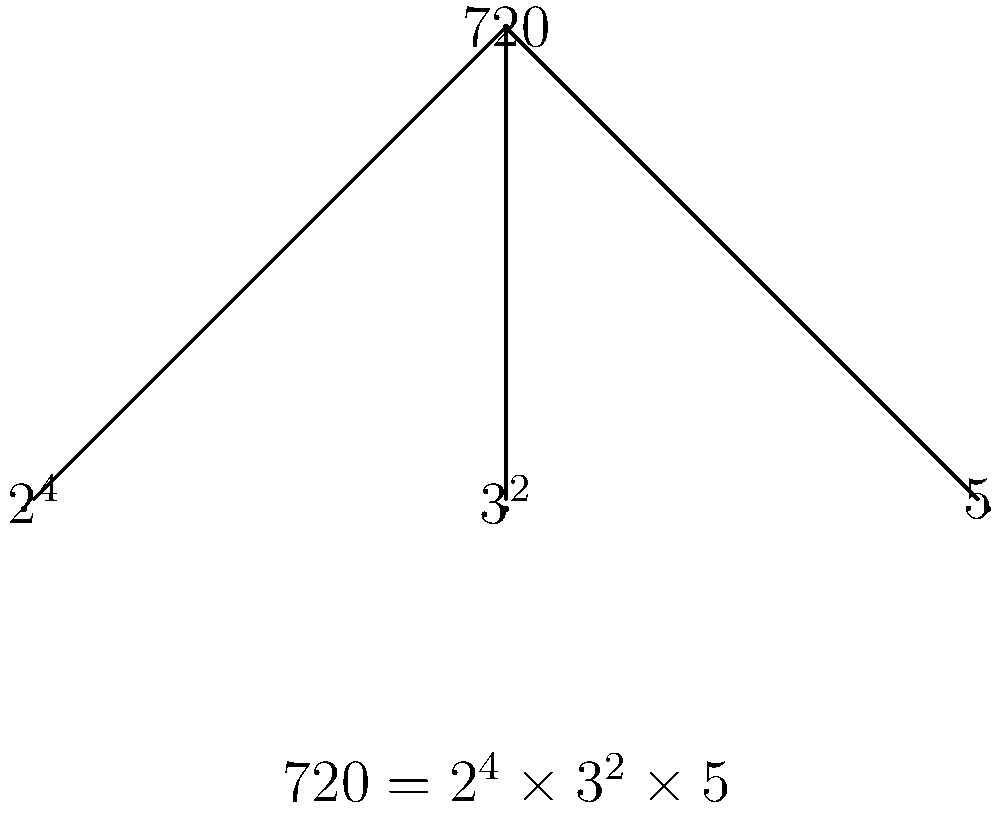Consider the group order factorization tree for a group $G$ of order 720. Based on Sylow's theorems, what can we conclude about the number of Sylow 5-subgroups in $G$? Provide your answer modulo 720. Let's approach this step-by-step using Sylow's theorems:

1) First, recall Sylow's theorems:
   - The number of Sylow p-subgroups, denoted $n_p$, divides the order of the group.
   - $n_p \equiv 1 \pmod{p}$

2) In this case, we're interested in Sylow 5-subgroups. The order of $G$ is 720.

3) From the factorization tree, we can see that $720 = 2^4 \times 3^2 \times 5$.

4) By Sylow's first theorem, $n_5$ must divide 720.

5) The divisors of 720 are: 1, 2, 3, 4, 5, 6, 8, 9, 10, 12, 15, 16, 18, 20, 24, 30, 36, 40, 45, 48, 60, 72, 80, 90, 120, 144, 180, 240, 360, 720.

6) By Sylow's third theorem, $n_5 \equiv 1 \pmod{5}$.

7) The only divisors of 720 that satisfy this condition are 1, 6, 16, 36, 71, 144.

8) Therefore, $n_5$ could be 1, 6, 16, 36, 71, or 144.

9) However, the question asks for the answer modulo 720. All of these possible values are already less than 720, so they remain unchanged when taken modulo 720.

Thus, without additional information about the specific structure of $G$, we can only conclude that $n_5 \equiv 1, 6, 16, 36, 71,$ or $144 \pmod{720}$.
Answer: $n_5 \equiv 1, 6, 16, 36, 71,$ or $144 \pmod{720}$ 